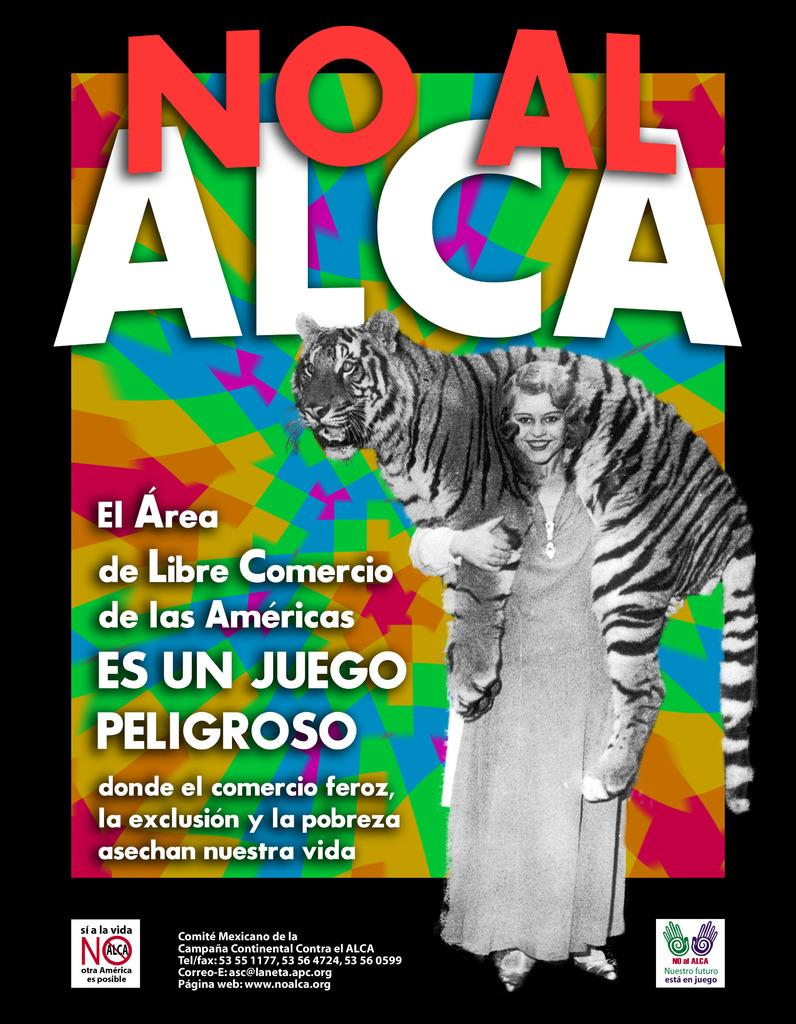What is present in the image? There is a poster in the image. What can be found on the poster? The poster contains images and text. What type of breakfast is being served in the image? There is no breakfast present in the image; it only features a poster with images and text. How many kittens can be seen playing on the poster? There are no kittens present on the poster; it contains images and text, but none of them feature kittens. 